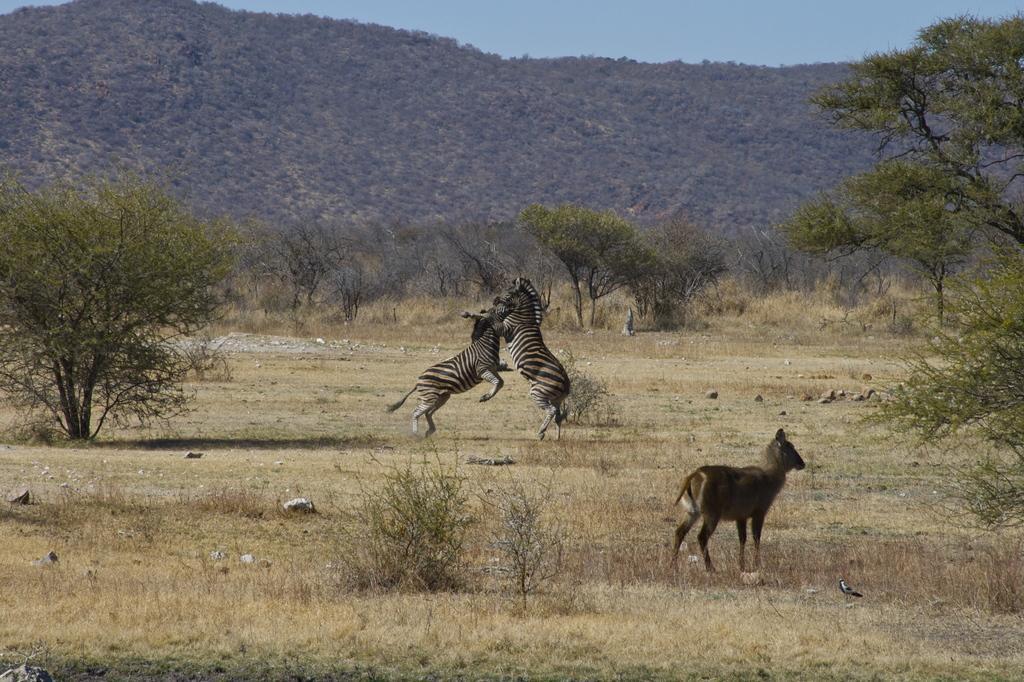Please provide a concise description of this image. In this image we can see two zebras on the ground, they are in black and white color, in front there is an animal, there are trees, here is the dried grass, there are mountains, at above here is the sky. 